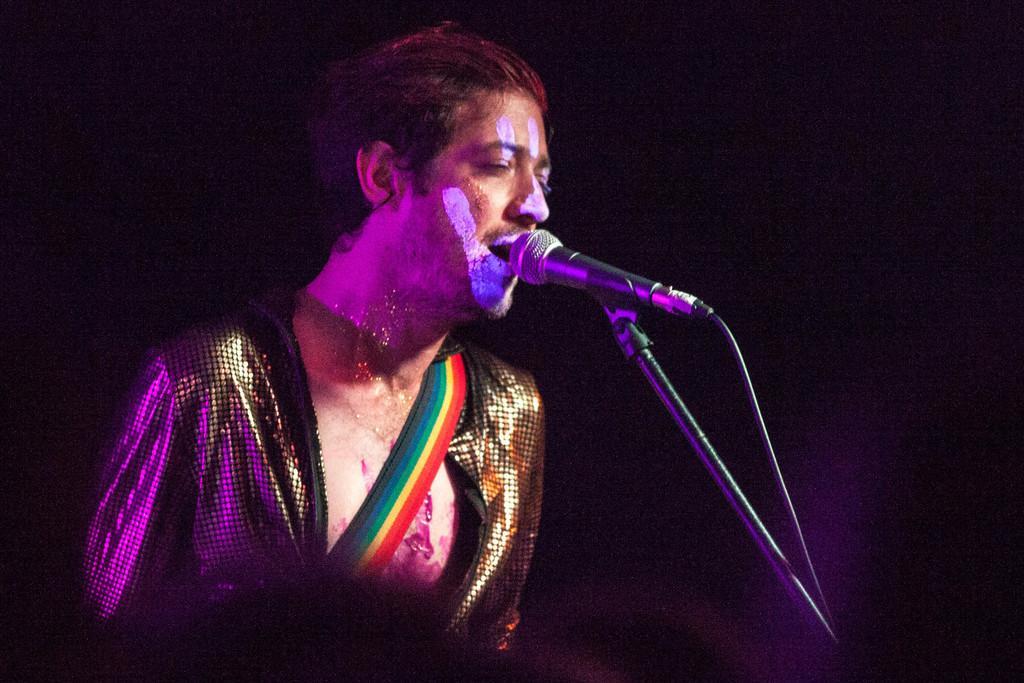Could you give a brief overview of what you see in this image? In this picture there is a man singing and there's a painting on his face. On the right side of the image there is a microphone on the stand. 